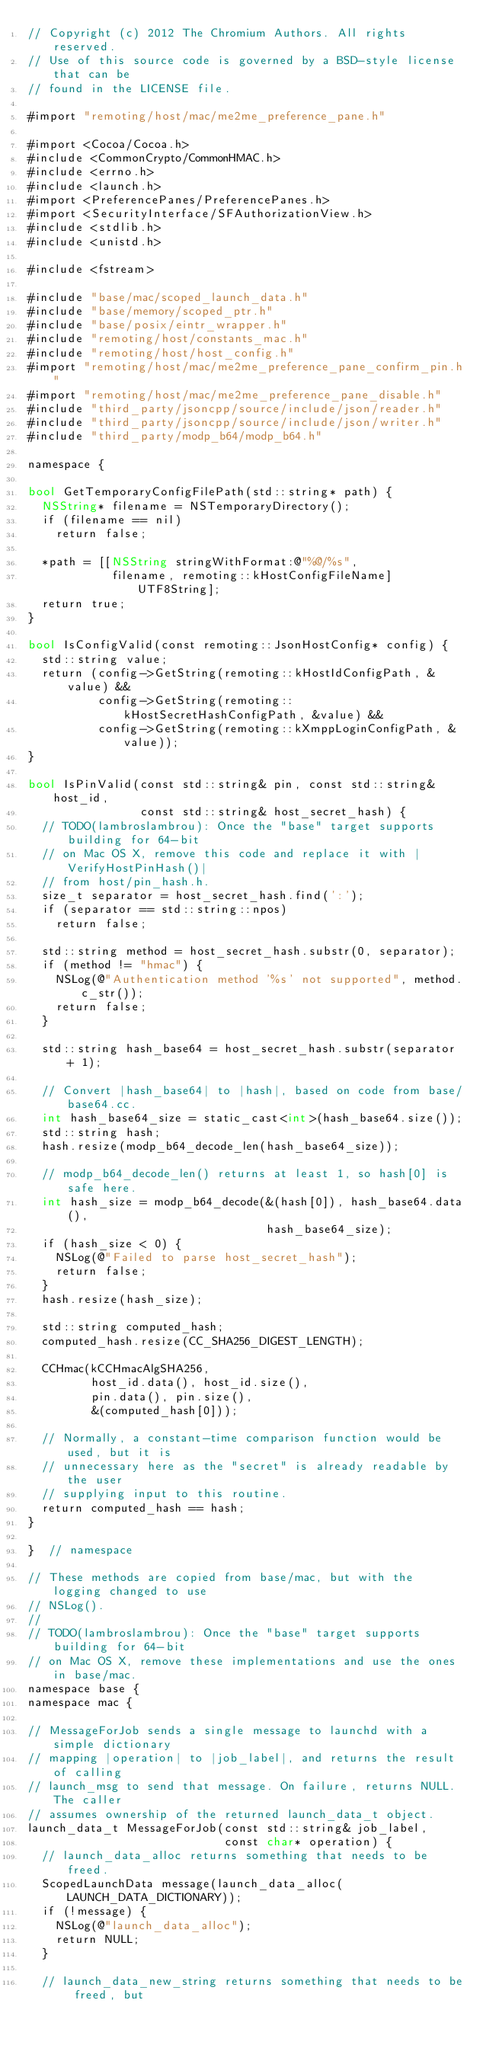Convert code to text. <code><loc_0><loc_0><loc_500><loc_500><_ObjectiveC_>// Copyright (c) 2012 The Chromium Authors. All rights reserved.
// Use of this source code is governed by a BSD-style license that can be
// found in the LICENSE file.

#import "remoting/host/mac/me2me_preference_pane.h"

#import <Cocoa/Cocoa.h>
#include <CommonCrypto/CommonHMAC.h>
#include <errno.h>
#include <launch.h>
#import <PreferencePanes/PreferencePanes.h>
#import <SecurityInterface/SFAuthorizationView.h>
#include <stdlib.h>
#include <unistd.h>

#include <fstream>

#include "base/mac/scoped_launch_data.h"
#include "base/memory/scoped_ptr.h"
#include "base/posix/eintr_wrapper.h"
#include "remoting/host/constants_mac.h"
#include "remoting/host/host_config.h"
#import "remoting/host/mac/me2me_preference_pane_confirm_pin.h"
#import "remoting/host/mac/me2me_preference_pane_disable.h"
#include "third_party/jsoncpp/source/include/json/reader.h"
#include "third_party/jsoncpp/source/include/json/writer.h"
#include "third_party/modp_b64/modp_b64.h"

namespace {

bool GetTemporaryConfigFilePath(std::string* path) {
  NSString* filename = NSTemporaryDirectory();
  if (filename == nil)
    return false;

  *path = [[NSString stringWithFormat:@"%@/%s",
            filename, remoting::kHostConfigFileName] UTF8String];
  return true;
}

bool IsConfigValid(const remoting::JsonHostConfig* config) {
  std::string value;
  return (config->GetString(remoting::kHostIdConfigPath, &value) &&
          config->GetString(remoting::kHostSecretHashConfigPath, &value) &&
          config->GetString(remoting::kXmppLoginConfigPath, &value));
}

bool IsPinValid(const std::string& pin, const std::string& host_id,
                const std::string& host_secret_hash) {
  // TODO(lambroslambrou): Once the "base" target supports building for 64-bit
  // on Mac OS X, remove this code and replace it with |VerifyHostPinHash()|
  // from host/pin_hash.h.
  size_t separator = host_secret_hash.find(':');
  if (separator == std::string::npos)
    return false;

  std::string method = host_secret_hash.substr(0, separator);
  if (method != "hmac") {
    NSLog(@"Authentication method '%s' not supported", method.c_str());
    return false;
  }

  std::string hash_base64 = host_secret_hash.substr(separator + 1);

  // Convert |hash_base64| to |hash|, based on code from base/base64.cc.
  int hash_base64_size = static_cast<int>(hash_base64.size());
  std::string hash;
  hash.resize(modp_b64_decode_len(hash_base64_size));

  // modp_b64_decode_len() returns at least 1, so hash[0] is safe here.
  int hash_size = modp_b64_decode(&(hash[0]), hash_base64.data(),
                                  hash_base64_size);
  if (hash_size < 0) {
    NSLog(@"Failed to parse host_secret_hash");
    return false;
  }
  hash.resize(hash_size);

  std::string computed_hash;
  computed_hash.resize(CC_SHA256_DIGEST_LENGTH);

  CCHmac(kCCHmacAlgSHA256,
         host_id.data(), host_id.size(),
         pin.data(), pin.size(),
         &(computed_hash[0]));

  // Normally, a constant-time comparison function would be used, but it is
  // unnecessary here as the "secret" is already readable by the user
  // supplying input to this routine.
  return computed_hash == hash;
}

}  // namespace

// These methods are copied from base/mac, but with the logging changed to use
// NSLog().
//
// TODO(lambroslambrou): Once the "base" target supports building for 64-bit
// on Mac OS X, remove these implementations and use the ones in base/mac.
namespace base {
namespace mac {

// MessageForJob sends a single message to launchd with a simple dictionary
// mapping |operation| to |job_label|, and returns the result of calling
// launch_msg to send that message. On failure, returns NULL. The caller
// assumes ownership of the returned launch_data_t object.
launch_data_t MessageForJob(const std::string& job_label,
                            const char* operation) {
  // launch_data_alloc returns something that needs to be freed.
  ScopedLaunchData message(launch_data_alloc(LAUNCH_DATA_DICTIONARY));
  if (!message) {
    NSLog(@"launch_data_alloc");
    return NULL;
  }

  // launch_data_new_string returns something that needs to be freed, but</code> 